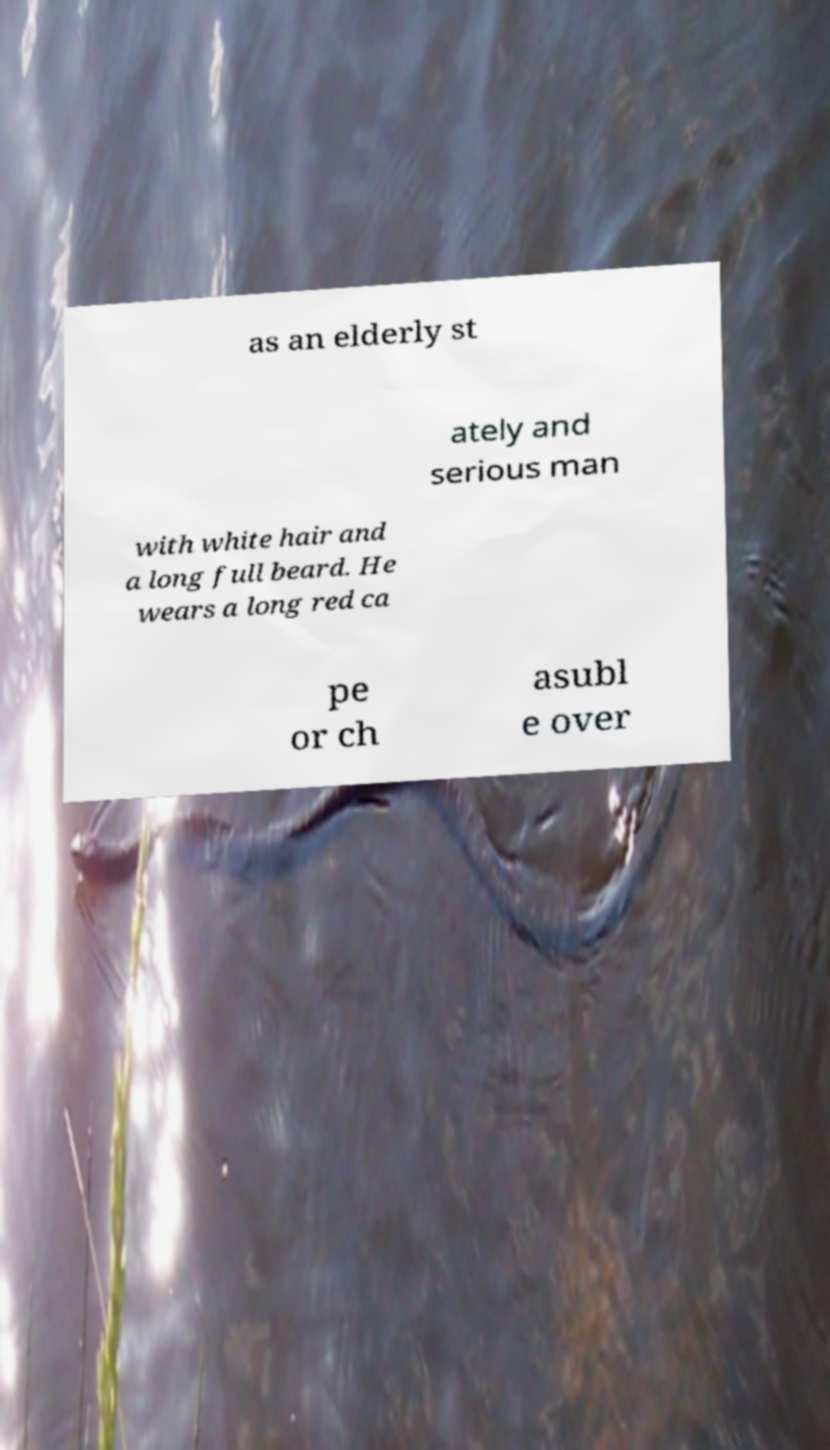I need the written content from this picture converted into text. Can you do that? as an elderly st ately and serious man with white hair and a long full beard. He wears a long red ca pe or ch asubl e over 